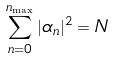<formula> <loc_0><loc_0><loc_500><loc_500>\sum ^ { n _ { \max } } _ { n = 0 } | \alpha _ { n } | ^ { 2 } = N</formula> 